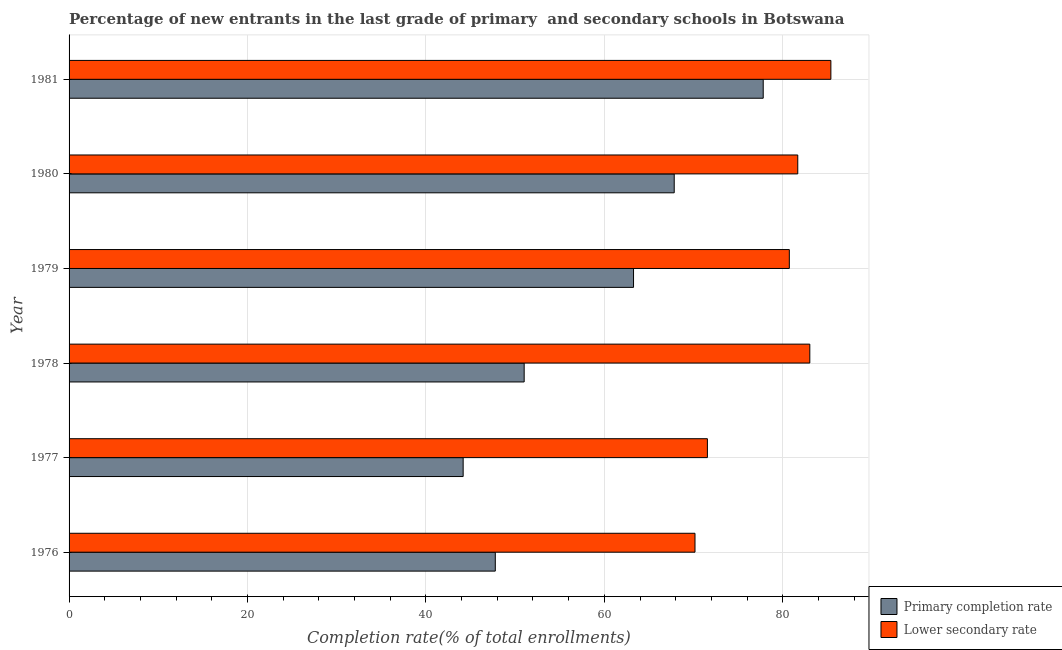How many different coloured bars are there?
Your answer should be compact. 2. How many bars are there on the 2nd tick from the bottom?
Provide a short and direct response. 2. What is the label of the 4th group of bars from the top?
Your answer should be compact. 1978. What is the completion rate in primary schools in 1976?
Offer a terse response. 47.78. Across all years, what is the maximum completion rate in secondary schools?
Your answer should be very brief. 85.39. Across all years, what is the minimum completion rate in primary schools?
Offer a very short reply. 44.17. In which year was the completion rate in primary schools maximum?
Provide a succinct answer. 1981. In which year was the completion rate in primary schools minimum?
Your response must be concise. 1977. What is the total completion rate in secondary schools in the graph?
Offer a terse response. 472.56. What is the difference between the completion rate in primary schools in 1978 and that in 1979?
Your answer should be compact. -12.26. What is the difference between the completion rate in secondary schools in 1979 and the completion rate in primary schools in 1977?
Your answer should be very brief. 36.56. What is the average completion rate in secondary schools per year?
Offer a very short reply. 78.76. In the year 1979, what is the difference between the completion rate in primary schools and completion rate in secondary schools?
Make the answer very short. -17.46. In how many years, is the completion rate in secondary schools greater than 36 %?
Ensure brevity in your answer.  6. What is the ratio of the completion rate in secondary schools in 1980 to that in 1981?
Keep it short and to the point. 0.96. What is the difference between the highest and the second highest completion rate in secondary schools?
Offer a very short reply. 2.36. What is the difference between the highest and the lowest completion rate in secondary schools?
Provide a short and direct response. 15.23. Is the sum of the completion rate in primary schools in 1977 and 1981 greater than the maximum completion rate in secondary schools across all years?
Provide a short and direct response. Yes. What does the 1st bar from the top in 1977 represents?
Provide a short and direct response. Lower secondary rate. What does the 1st bar from the bottom in 1979 represents?
Provide a succinct answer. Primary completion rate. Are all the bars in the graph horizontal?
Ensure brevity in your answer.  Yes. Does the graph contain any zero values?
Provide a succinct answer. No. Where does the legend appear in the graph?
Offer a very short reply. Bottom right. How many legend labels are there?
Offer a terse response. 2. What is the title of the graph?
Provide a short and direct response. Percentage of new entrants in the last grade of primary  and secondary schools in Botswana. Does "Education" appear as one of the legend labels in the graph?
Offer a terse response. No. What is the label or title of the X-axis?
Ensure brevity in your answer.  Completion rate(% of total enrollments). What is the label or title of the Y-axis?
Your answer should be compact. Year. What is the Completion rate(% of total enrollments) of Primary completion rate in 1976?
Keep it short and to the point. 47.78. What is the Completion rate(% of total enrollments) of Lower secondary rate in 1976?
Provide a short and direct response. 70.16. What is the Completion rate(% of total enrollments) in Primary completion rate in 1977?
Your answer should be compact. 44.17. What is the Completion rate(% of total enrollments) in Lower secondary rate in 1977?
Your response must be concise. 71.55. What is the Completion rate(% of total enrollments) in Primary completion rate in 1978?
Offer a very short reply. 51.01. What is the Completion rate(% of total enrollments) in Lower secondary rate in 1978?
Your answer should be compact. 83.03. What is the Completion rate(% of total enrollments) of Primary completion rate in 1979?
Ensure brevity in your answer.  63.27. What is the Completion rate(% of total enrollments) of Lower secondary rate in 1979?
Provide a short and direct response. 80.74. What is the Completion rate(% of total enrollments) of Primary completion rate in 1980?
Provide a short and direct response. 67.83. What is the Completion rate(% of total enrollments) in Lower secondary rate in 1980?
Offer a terse response. 81.68. What is the Completion rate(% of total enrollments) of Primary completion rate in 1981?
Make the answer very short. 77.81. What is the Completion rate(% of total enrollments) in Lower secondary rate in 1981?
Your answer should be compact. 85.39. Across all years, what is the maximum Completion rate(% of total enrollments) in Primary completion rate?
Offer a terse response. 77.81. Across all years, what is the maximum Completion rate(% of total enrollments) in Lower secondary rate?
Provide a succinct answer. 85.39. Across all years, what is the minimum Completion rate(% of total enrollments) in Primary completion rate?
Keep it short and to the point. 44.17. Across all years, what is the minimum Completion rate(% of total enrollments) in Lower secondary rate?
Provide a succinct answer. 70.16. What is the total Completion rate(% of total enrollments) in Primary completion rate in the graph?
Your answer should be compact. 351.89. What is the total Completion rate(% of total enrollments) of Lower secondary rate in the graph?
Make the answer very short. 472.56. What is the difference between the Completion rate(% of total enrollments) of Primary completion rate in 1976 and that in 1977?
Offer a terse response. 3.6. What is the difference between the Completion rate(% of total enrollments) in Lower secondary rate in 1976 and that in 1977?
Make the answer very short. -1.39. What is the difference between the Completion rate(% of total enrollments) of Primary completion rate in 1976 and that in 1978?
Provide a short and direct response. -3.24. What is the difference between the Completion rate(% of total enrollments) in Lower secondary rate in 1976 and that in 1978?
Offer a very short reply. -12.87. What is the difference between the Completion rate(% of total enrollments) in Primary completion rate in 1976 and that in 1979?
Provide a succinct answer. -15.49. What is the difference between the Completion rate(% of total enrollments) in Lower secondary rate in 1976 and that in 1979?
Ensure brevity in your answer.  -10.57. What is the difference between the Completion rate(% of total enrollments) of Primary completion rate in 1976 and that in 1980?
Your answer should be very brief. -20.06. What is the difference between the Completion rate(% of total enrollments) of Lower secondary rate in 1976 and that in 1980?
Provide a short and direct response. -11.52. What is the difference between the Completion rate(% of total enrollments) in Primary completion rate in 1976 and that in 1981?
Offer a terse response. -30.03. What is the difference between the Completion rate(% of total enrollments) of Lower secondary rate in 1976 and that in 1981?
Offer a terse response. -15.23. What is the difference between the Completion rate(% of total enrollments) of Primary completion rate in 1977 and that in 1978?
Make the answer very short. -6.84. What is the difference between the Completion rate(% of total enrollments) in Lower secondary rate in 1977 and that in 1978?
Make the answer very short. -11.48. What is the difference between the Completion rate(% of total enrollments) of Primary completion rate in 1977 and that in 1979?
Your response must be concise. -19.1. What is the difference between the Completion rate(% of total enrollments) in Lower secondary rate in 1977 and that in 1979?
Your answer should be very brief. -9.18. What is the difference between the Completion rate(% of total enrollments) of Primary completion rate in 1977 and that in 1980?
Provide a short and direct response. -23.66. What is the difference between the Completion rate(% of total enrollments) of Lower secondary rate in 1977 and that in 1980?
Your answer should be very brief. -10.13. What is the difference between the Completion rate(% of total enrollments) in Primary completion rate in 1977 and that in 1981?
Give a very brief answer. -33.64. What is the difference between the Completion rate(% of total enrollments) in Lower secondary rate in 1977 and that in 1981?
Offer a terse response. -13.84. What is the difference between the Completion rate(% of total enrollments) in Primary completion rate in 1978 and that in 1979?
Keep it short and to the point. -12.26. What is the difference between the Completion rate(% of total enrollments) in Lower secondary rate in 1978 and that in 1979?
Give a very brief answer. 2.3. What is the difference between the Completion rate(% of total enrollments) of Primary completion rate in 1978 and that in 1980?
Provide a short and direct response. -16.82. What is the difference between the Completion rate(% of total enrollments) in Lower secondary rate in 1978 and that in 1980?
Your answer should be compact. 1.35. What is the difference between the Completion rate(% of total enrollments) in Primary completion rate in 1978 and that in 1981?
Offer a terse response. -26.79. What is the difference between the Completion rate(% of total enrollments) in Lower secondary rate in 1978 and that in 1981?
Provide a short and direct response. -2.36. What is the difference between the Completion rate(% of total enrollments) of Primary completion rate in 1979 and that in 1980?
Make the answer very short. -4.56. What is the difference between the Completion rate(% of total enrollments) in Lower secondary rate in 1979 and that in 1980?
Give a very brief answer. -0.95. What is the difference between the Completion rate(% of total enrollments) in Primary completion rate in 1979 and that in 1981?
Your response must be concise. -14.54. What is the difference between the Completion rate(% of total enrollments) of Lower secondary rate in 1979 and that in 1981?
Ensure brevity in your answer.  -4.66. What is the difference between the Completion rate(% of total enrollments) of Primary completion rate in 1980 and that in 1981?
Your response must be concise. -9.98. What is the difference between the Completion rate(% of total enrollments) in Lower secondary rate in 1980 and that in 1981?
Provide a short and direct response. -3.71. What is the difference between the Completion rate(% of total enrollments) of Primary completion rate in 1976 and the Completion rate(% of total enrollments) of Lower secondary rate in 1977?
Provide a short and direct response. -23.78. What is the difference between the Completion rate(% of total enrollments) of Primary completion rate in 1976 and the Completion rate(% of total enrollments) of Lower secondary rate in 1978?
Provide a short and direct response. -35.26. What is the difference between the Completion rate(% of total enrollments) in Primary completion rate in 1976 and the Completion rate(% of total enrollments) in Lower secondary rate in 1979?
Provide a succinct answer. -32.96. What is the difference between the Completion rate(% of total enrollments) of Primary completion rate in 1976 and the Completion rate(% of total enrollments) of Lower secondary rate in 1980?
Offer a very short reply. -33.9. What is the difference between the Completion rate(% of total enrollments) of Primary completion rate in 1976 and the Completion rate(% of total enrollments) of Lower secondary rate in 1981?
Ensure brevity in your answer.  -37.62. What is the difference between the Completion rate(% of total enrollments) of Primary completion rate in 1977 and the Completion rate(% of total enrollments) of Lower secondary rate in 1978?
Give a very brief answer. -38.86. What is the difference between the Completion rate(% of total enrollments) of Primary completion rate in 1977 and the Completion rate(% of total enrollments) of Lower secondary rate in 1979?
Give a very brief answer. -36.56. What is the difference between the Completion rate(% of total enrollments) in Primary completion rate in 1977 and the Completion rate(% of total enrollments) in Lower secondary rate in 1980?
Your answer should be compact. -37.51. What is the difference between the Completion rate(% of total enrollments) in Primary completion rate in 1977 and the Completion rate(% of total enrollments) in Lower secondary rate in 1981?
Your response must be concise. -41.22. What is the difference between the Completion rate(% of total enrollments) in Primary completion rate in 1978 and the Completion rate(% of total enrollments) in Lower secondary rate in 1979?
Provide a succinct answer. -29.72. What is the difference between the Completion rate(% of total enrollments) in Primary completion rate in 1978 and the Completion rate(% of total enrollments) in Lower secondary rate in 1980?
Provide a succinct answer. -30.67. What is the difference between the Completion rate(% of total enrollments) of Primary completion rate in 1978 and the Completion rate(% of total enrollments) of Lower secondary rate in 1981?
Make the answer very short. -34.38. What is the difference between the Completion rate(% of total enrollments) of Primary completion rate in 1979 and the Completion rate(% of total enrollments) of Lower secondary rate in 1980?
Your response must be concise. -18.41. What is the difference between the Completion rate(% of total enrollments) in Primary completion rate in 1979 and the Completion rate(% of total enrollments) in Lower secondary rate in 1981?
Your answer should be very brief. -22.12. What is the difference between the Completion rate(% of total enrollments) of Primary completion rate in 1980 and the Completion rate(% of total enrollments) of Lower secondary rate in 1981?
Make the answer very short. -17.56. What is the average Completion rate(% of total enrollments) of Primary completion rate per year?
Give a very brief answer. 58.65. What is the average Completion rate(% of total enrollments) of Lower secondary rate per year?
Your answer should be very brief. 78.76. In the year 1976, what is the difference between the Completion rate(% of total enrollments) in Primary completion rate and Completion rate(% of total enrollments) in Lower secondary rate?
Offer a terse response. -22.38. In the year 1977, what is the difference between the Completion rate(% of total enrollments) of Primary completion rate and Completion rate(% of total enrollments) of Lower secondary rate?
Make the answer very short. -27.38. In the year 1978, what is the difference between the Completion rate(% of total enrollments) of Primary completion rate and Completion rate(% of total enrollments) of Lower secondary rate?
Provide a short and direct response. -32.02. In the year 1979, what is the difference between the Completion rate(% of total enrollments) of Primary completion rate and Completion rate(% of total enrollments) of Lower secondary rate?
Give a very brief answer. -17.46. In the year 1980, what is the difference between the Completion rate(% of total enrollments) in Primary completion rate and Completion rate(% of total enrollments) in Lower secondary rate?
Offer a very short reply. -13.85. In the year 1981, what is the difference between the Completion rate(% of total enrollments) in Primary completion rate and Completion rate(% of total enrollments) in Lower secondary rate?
Give a very brief answer. -7.58. What is the ratio of the Completion rate(% of total enrollments) of Primary completion rate in 1976 to that in 1977?
Provide a succinct answer. 1.08. What is the ratio of the Completion rate(% of total enrollments) of Lower secondary rate in 1976 to that in 1977?
Your answer should be very brief. 0.98. What is the ratio of the Completion rate(% of total enrollments) of Primary completion rate in 1976 to that in 1978?
Your answer should be very brief. 0.94. What is the ratio of the Completion rate(% of total enrollments) in Lower secondary rate in 1976 to that in 1978?
Offer a very short reply. 0.84. What is the ratio of the Completion rate(% of total enrollments) of Primary completion rate in 1976 to that in 1979?
Provide a short and direct response. 0.76. What is the ratio of the Completion rate(% of total enrollments) in Lower secondary rate in 1976 to that in 1979?
Offer a very short reply. 0.87. What is the ratio of the Completion rate(% of total enrollments) of Primary completion rate in 1976 to that in 1980?
Make the answer very short. 0.7. What is the ratio of the Completion rate(% of total enrollments) in Lower secondary rate in 1976 to that in 1980?
Provide a succinct answer. 0.86. What is the ratio of the Completion rate(% of total enrollments) of Primary completion rate in 1976 to that in 1981?
Keep it short and to the point. 0.61. What is the ratio of the Completion rate(% of total enrollments) in Lower secondary rate in 1976 to that in 1981?
Offer a very short reply. 0.82. What is the ratio of the Completion rate(% of total enrollments) of Primary completion rate in 1977 to that in 1978?
Your answer should be very brief. 0.87. What is the ratio of the Completion rate(% of total enrollments) in Lower secondary rate in 1977 to that in 1978?
Your response must be concise. 0.86. What is the ratio of the Completion rate(% of total enrollments) in Primary completion rate in 1977 to that in 1979?
Ensure brevity in your answer.  0.7. What is the ratio of the Completion rate(% of total enrollments) of Lower secondary rate in 1977 to that in 1979?
Offer a very short reply. 0.89. What is the ratio of the Completion rate(% of total enrollments) in Primary completion rate in 1977 to that in 1980?
Your answer should be compact. 0.65. What is the ratio of the Completion rate(% of total enrollments) of Lower secondary rate in 1977 to that in 1980?
Your response must be concise. 0.88. What is the ratio of the Completion rate(% of total enrollments) of Primary completion rate in 1977 to that in 1981?
Provide a short and direct response. 0.57. What is the ratio of the Completion rate(% of total enrollments) of Lower secondary rate in 1977 to that in 1981?
Offer a terse response. 0.84. What is the ratio of the Completion rate(% of total enrollments) of Primary completion rate in 1978 to that in 1979?
Your answer should be compact. 0.81. What is the ratio of the Completion rate(% of total enrollments) in Lower secondary rate in 1978 to that in 1979?
Your answer should be compact. 1.03. What is the ratio of the Completion rate(% of total enrollments) in Primary completion rate in 1978 to that in 1980?
Give a very brief answer. 0.75. What is the ratio of the Completion rate(% of total enrollments) of Lower secondary rate in 1978 to that in 1980?
Offer a terse response. 1.02. What is the ratio of the Completion rate(% of total enrollments) in Primary completion rate in 1978 to that in 1981?
Offer a very short reply. 0.66. What is the ratio of the Completion rate(% of total enrollments) in Lower secondary rate in 1978 to that in 1981?
Your response must be concise. 0.97. What is the ratio of the Completion rate(% of total enrollments) of Primary completion rate in 1979 to that in 1980?
Offer a very short reply. 0.93. What is the ratio of the Completion rate(% of total enrollments) in Lower secondary rate in 1979 to that in 1980?
Your response must be concise. 0.99. What is the ratio of the Completion rate(% of total enrollments) of Primary completion rate in 1979 to that in 1981?
Offer a very short reply. 0.81. What is the ratio of the Completion rate(% of total enrollments) of Lower secondary rate in 1979 to that in 1981?
Your response must be concise. 0.95. What is the ratio of the Completion rate(% of total enrollments) of Primary completion rate in 1980 to that in 1981?
Provide a succinct answer. 0.87. What is the ratio of the Completion rate(% of total enrollments) of Lower secondary rate in 1980 to that in 1981?
Your answer should be very brief. 0.96. What is the difference between the highest and the second highest Completion rate(% of total enrollments) in Primary completion rate?
Your answer should be compact. 9.98. What is the difference between the highest and the second highest Completion rate(% of total enrollments) in Lower secondary rate?
Keep it short and to the point. 2.36. What is the difference between the highest and the lowest Completion rate(% of total enrollments) of Primary completion rate?
Provide a short and direct response. 33.64. What is the difference between the highest and the lowest Completion rate(% of total enrollments) in Lower secondary rate?
Keep it short and to the point. 15.23. 